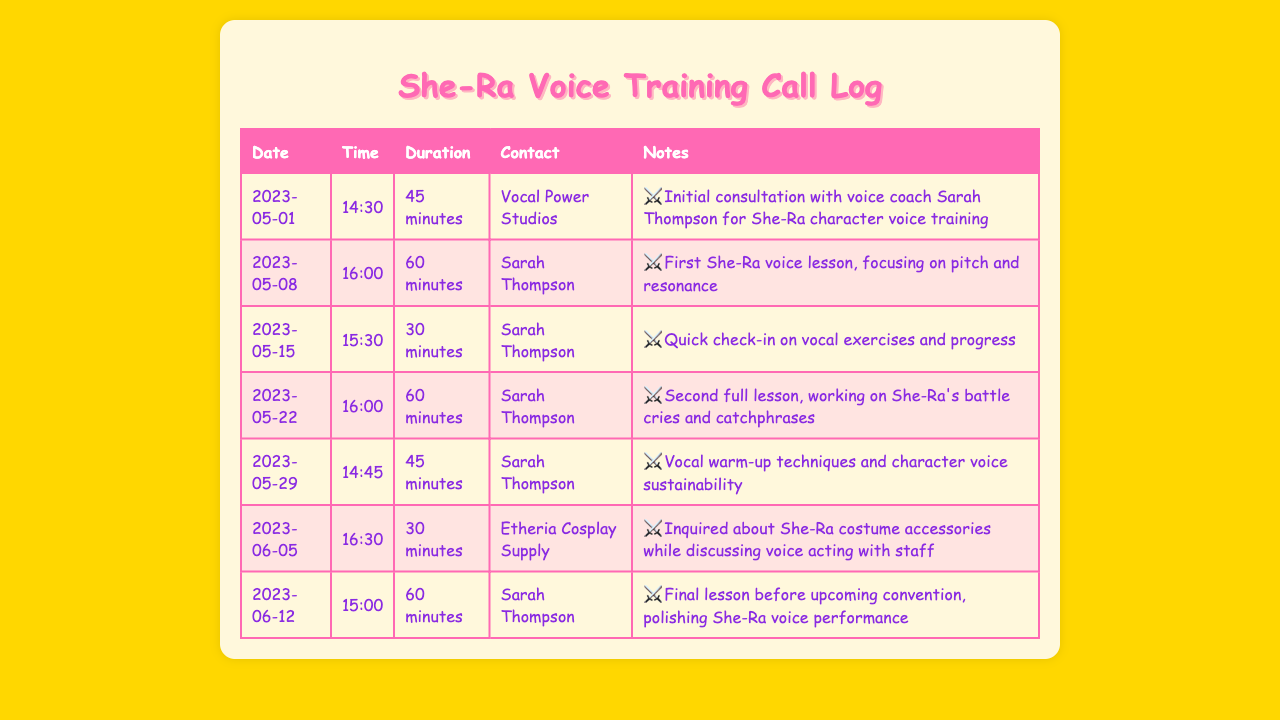what is the date of the initial consultation? The initial consultation with the voice coach Sarah Thompson took place on May 1, 2023.
Answer: May 1, 2023 who was the voice coach for the training? The voice coach listed in the call log is Sarah Thompson.
Answer: Sarah Thompson how long was the second full lesson? The second full lesson, working on She-Ra's battle cries, lasted 60 minutes.
Answer: 60 minutes what type of techniques were covered in the session on May 29? The session on May 29 focused on vocal warm-up techniques and character voice sustainability.
Answer: vocal warm-up techniques how many total lessons did Sarah Thompson conduct? There were a total of four lessons conducted by Sarah Thompson as per the log entries.
Answer: four lessons what was discussed during the call to Etheria Cosplay Supply? During the call, there was an inquiry regarding She-Ra costume accessories while discussing voice acting.
Answer: She-Ra costume accessories when was the final lesson held? The final lesson before the upcoming convention was held on June 12, 2023.
Answer: June 12, 2023 what was the duration of the quick check-in on May 15? The quick check-in on May 15 had a duration of 30 minutes.
Answer: 30 minutes how many minutes was the longest session with Sarah Thompson? The longest session recorded with Sarah Thompson was 60 minutes.
Answer: 60 minutes 